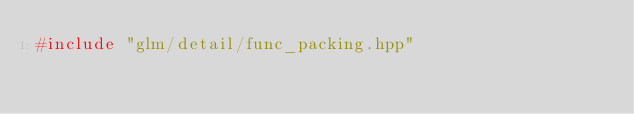<code> <loc_0><loc_0><loc_500><loc_500><_C++_>#include "glm/detail/func_packing.hpp"
</code> 